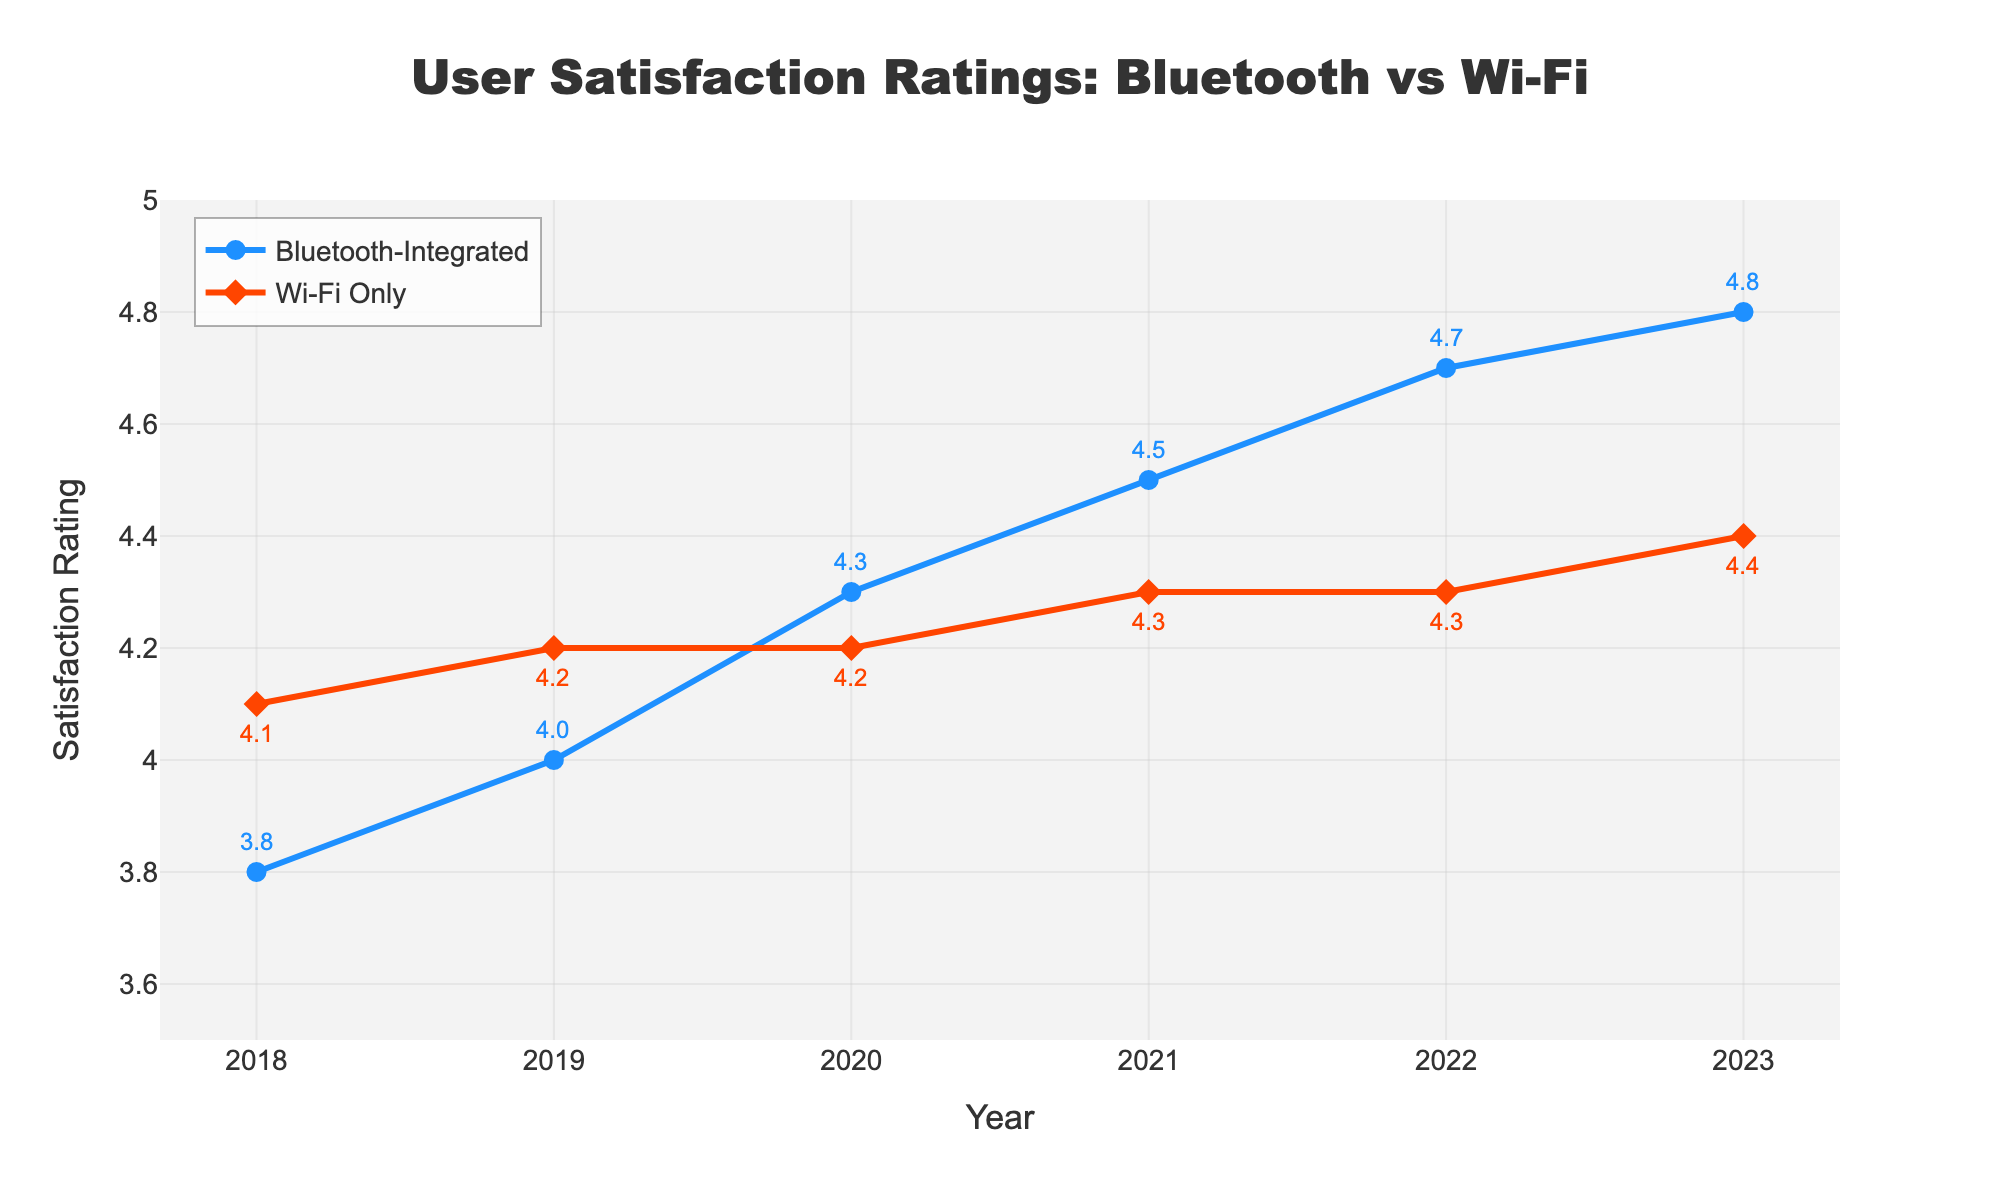What is the satisfaction rating for Bluetooth-integrated products in 2023? The satisfaction rating for Bluetooth-integrated products in 2023 is shown in the figure directly above the respective point on the x-axis labeled 2023. The annotation beside it indicates its value.
Answer: 4.8 What was the satisfaction rating for Wi-Fi only products in 2018? The satisfaction rating for Wi-Fi only products in 2018 is displayed as an annotated value near the point corresponding to 2018 on the x-axis labeled "Wi-Fi Only".
Answer: 4.1 How much did the satisfaction rating for Bluetooth-integrated products increase from 2018 to 2023? To find the increase, subtract the 2018 satisfaction rating from the 2023 rating. The ratings are 4.8 (2023) and 3.8 (2018), so 4.8 - 3.8 = 1.0.
Answer: 1.0 In which year did Bluetooth-integrated products surpass Wi-Fi only products in user satisfaction ratings? By observing the points where the Bluetooth-integrated line crosses the Wi-Fi only line, we can see Bluetooth-integrated first surpasses Wi-Fi only in the year 2020.
Answer: 2020 What is the average satisfaction rating of Wi-Fi only products over the 6-year period? To find the average, add the ratings for each year and divide by the number of years: (4.1 + 4.2 + 4.2 + 4.3 + 4.3 + 4.4) / 6 = 4.25.
Answer: 4.25 Compare the satisfaction rating trends of Bluetooth-integrated products and Wi-Fi only products from 2018 to 2023. Bluetooth-integrated products show a consistent increase in satisfaction ratings each year, while Wi-Fi only products have a relatively stable trend with minor increases.
Answer: Bluetooth-integrated: Increasing; Wi-Fi only: Stable Which year had the smallest difference in satisfaction ratings between Bluetooth-integrated and Wi-Fi only products? To find the smallest difference, subtract the Wi-Fi only rating from the Bluetooth-integrated rating for each year and find the minimum. The differences are: 2018: 3.8-4.1=-0.3, 2019: 4.0-4.2=-0.2, 2020: 4.3-4.2=0.1, 2021: 4.5-4.3=0.2, 2022: 4.7-4.3=0.4, 2023: 4.8-4.4=0.4. The smallest absolute difference is in 2020.
Answer: 2020 How does the satisfaction rating change of Wi-Fi only products between 2022 and 2023 compare to that of Bluetooth-integrated products? For Wi-Fi only products, the change is 4.4 - 4.3 = 0.1. For Bluetooth-integrated products, the change is 4.8 - 4.7 = 0.1. Both changes are the same.
Answer: The changes are the same, both 0.1 What's the overall trend in user satisfaction ratings for Bluetooth-integrated products from 2018 to 2023 based on the visual attributes? The line representing Bluetooth-integrated products shows a clear upward trend, indicating increasing satisfaction over the years. The increasing slope and annotations confirm this rise.
Answer: Increasing 